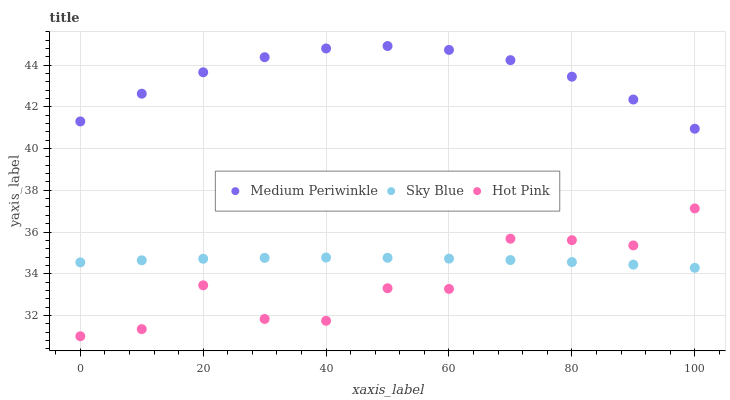Does Hot Pink have the minimum area under the curve?
Answer yes or no. Yes. Does Medium Periwinkle have the maximum area under the curve?
Answer yes or no. Yes. Does Medium Periwinkle have the minimum area under the curve?
Answer yes or no. No. Does Hot Pink have the maximum area under the curve?
Answer yes or no. No. Is Sky Blue the smoothest?
Answer yes or no. Yes. Is Hot Pink the roughest?
Answer yes or no. Yes. Is Medium Periwinkle the smoothest?
Answer yes or no. No. Is Medium Periwinkle the roughest?
Answer yes or no. No. Does Hot Pink have the lowest value?
Answer yes or no. Yes. Does Medium Periwinkle have the lowest value?
Answer yes or no. No. Does Medium Periwinkle have the highest value?
Answer yes or no. Yes. Does Hot Pink have the highest value?
Answer yes or no. No. Is Hot Pink less than Medium Periwinkle?
Answer yes or no. Yes. Is Medium Periwinkle greater than Hot Pink?
Answer yes or no. Yes. Does Sky Blue intersect Hot Pink?
Answer yes or no. Yes. Is Sky Blue less than Hot Pink?
Answer yes or no. No. Is Sky Blue greater than Hot Pink?
Answer yes or no. No. Does Hot Pink intersect Medium Periwinkle?
Answer yes or no. No. 